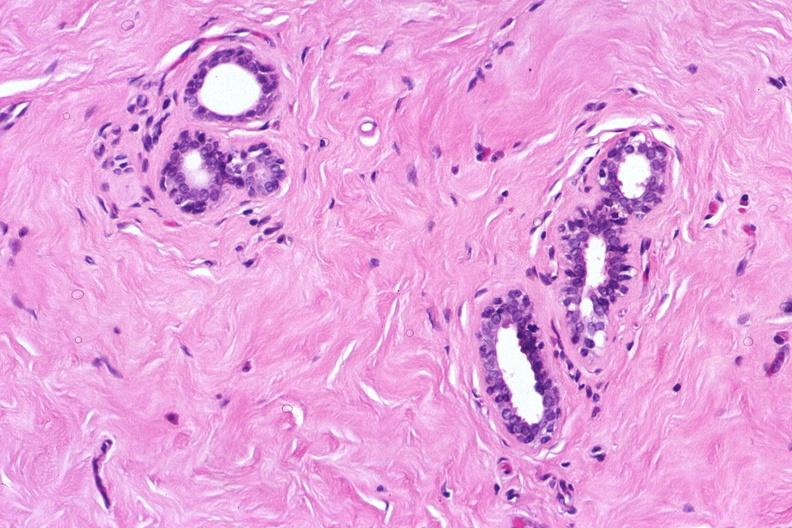does breast show normal breast?
Answer the question using a single word or phrase. No 